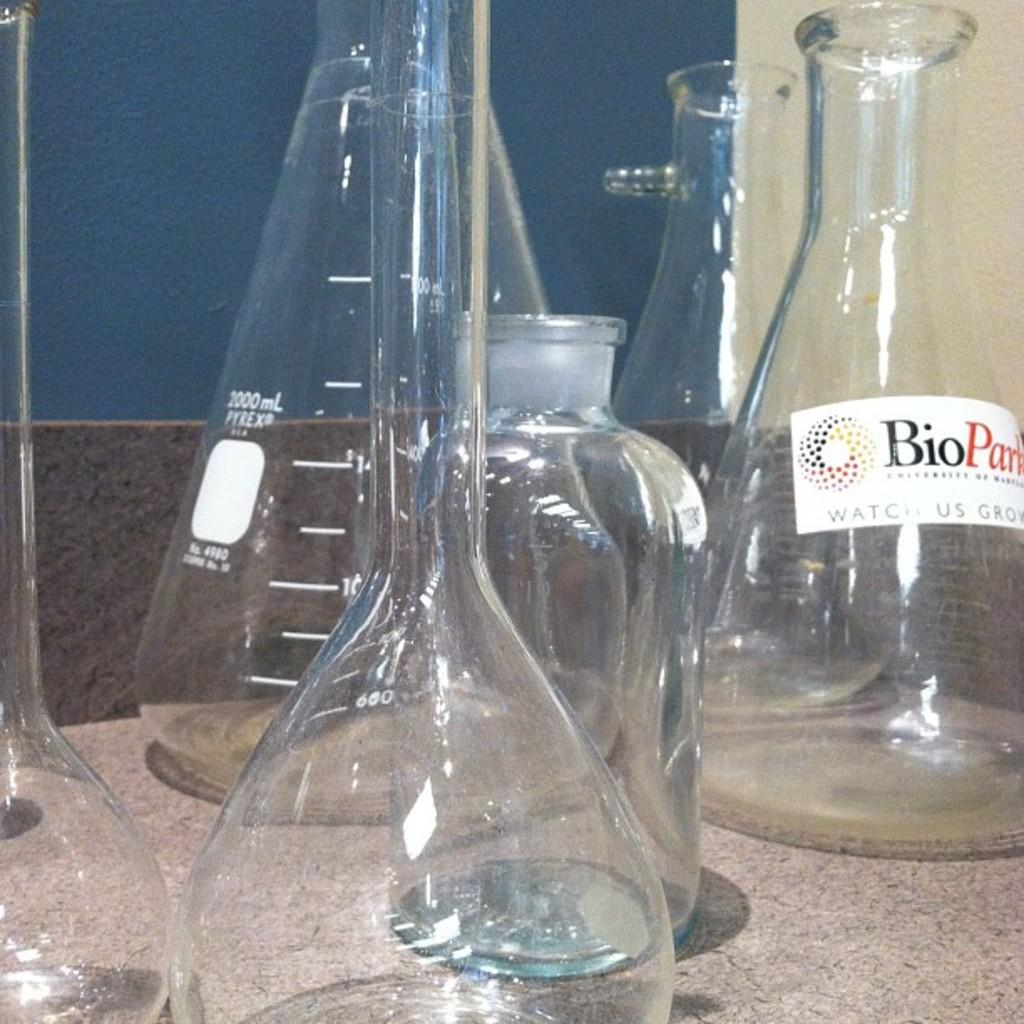Provide a one-sentence caption for the provided image. a few glasses and one with a Bio word on it. 